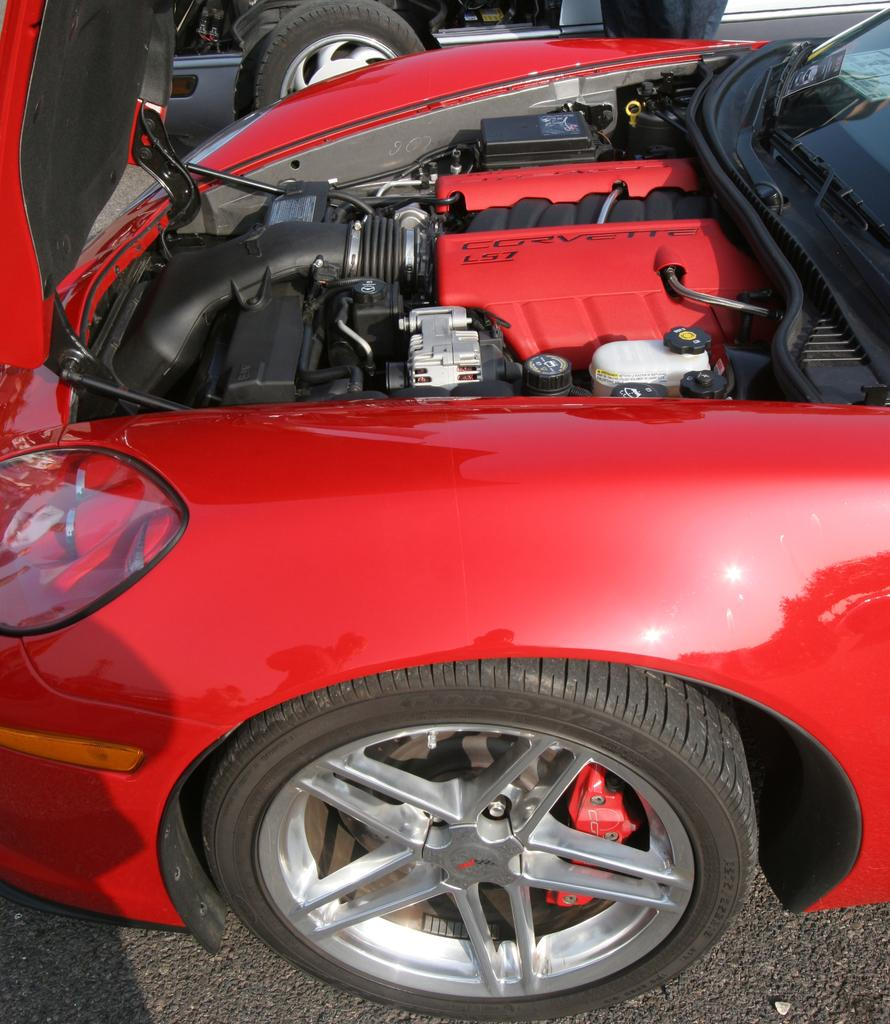What type of vehicles can be seen on the road in the image? There are motor vehicles on the road in the image. What month is it in the image? The month cannot be determined from the image, as there is no information about the time of year or any seasonal indicators present. 